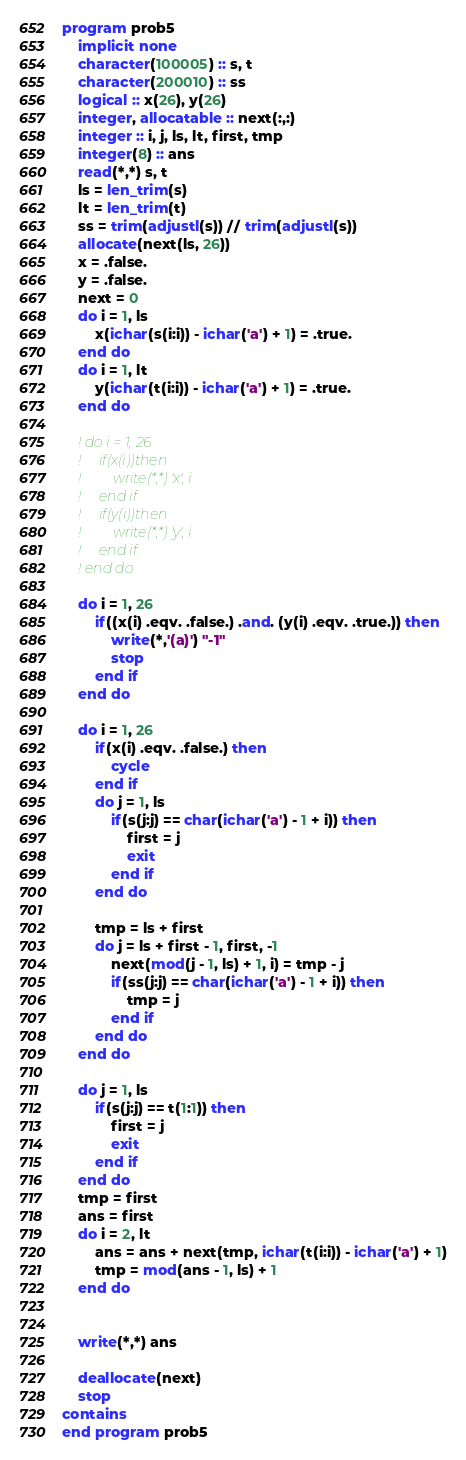Convert code to text. <code><loc_0><loc_0><loc_500><loc_500><_FORTRAN_>program prob5
    implicit none
    character(100005) :: s, t
    character(200010) :: ss
    logical :: x(26), y(26)
    integer, allocatable :: next(:,:)
    integer :: i, j, ls, lt, first, tmp
    integer(8) :: ans
    read(*,*) s, t
    ls = len_trim(s)
    lt = len_trim(t)
    ss = trim(adjustl(s)) // trim(adjustl(s))
    allocate(next(ls, 26))
    x = .false.
    y = .false.
    next = 0
    do i = 1, ls
        x(ichar(s(i:i)) - ichar('a') + 1) = .true.
    end do
    do i = 1, lt
        y(ichar(t(i:i)) - ichar('a') + 1) = .true.
    end do

    ! do i = 1, 26
    !     if(x(i))then
    !         write(*,*) 'x', i
    !     end if
    !     if(y(i))then
    !         write(*,*) 'y', i
    !     end if
    ! end do

    do i = 1, 26
        if((x(i) .eqv. .false.) .and. (y(i) .eqv. .true.)) then
            write(*,'(a)') "-1"
            stop
        end if
    end do

    do i = 1, 26
        if(x(i) .eqv. .false.) then
            cycle
        end if
        do j = 1, ls
            if(s(j:j) == char(ichar('a') - 1 + i)) then
                first = j
                exit
            end if
        end do

        tmp = ls + first
        do j = ls + first - 1, first, -1
            next(mod(j - 1, ls) + 1, i) = tmp - j
            if(ss(j:j) == char(ichar('a') - 1 + i)) then
                tmp = j
            end if
        end do
    end do

    do j = 1, ls
        if(s(j:j) == t(1:1)) then
            first = j
            exit
        end if
    end do
    tmp = first
    ans = first
    do i = 2, lt
        ans = ans + next(tmp, ichar(t(i:i)) - ichar('a') + 1)
        tmp = mod(ans - 1, ls) + 1
    end do


    write(*,*) ans

    deallocate(next)
    stop
contains
end program prob5</code> 